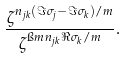Convert formula to latex. <formula><loc_0><loc_0><loc_500><loc_500>\frac { \zeta ^ { n _ { j k } ( \Im \sigma _ { j } - \Im \sigma _ { k } ) / m } } { \zeta ^ { \i m n _ { j k } \Re \sigma _ { k } / m } } .</formula> 